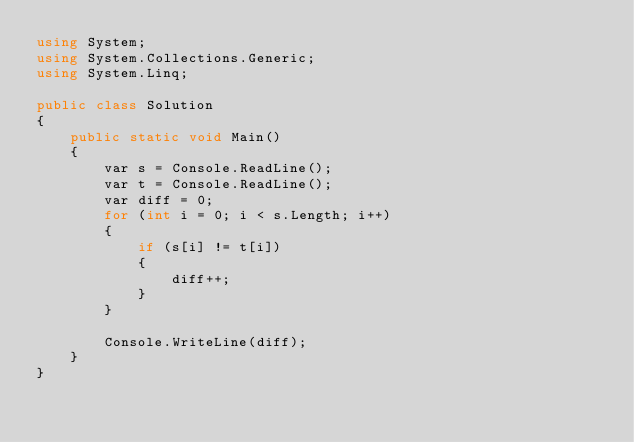Convert code to text. <code><loc_0><loc_0><loc_500><loc_500><_C#_>using System;
using System.Collections.Generic;
using System.Linq;

public class Solution
{
    public static void Main()
    {
        var s = Console.ReadLine();
        var t = Console.ReadLine();
        var diff = 0;
        for (int i = 0; i < s.Length; i++)
        {
            if (s[i] != t[i])
            {
                diff++;
            }
        }

        Console.WriteLine(diff);
    }
}</code> 